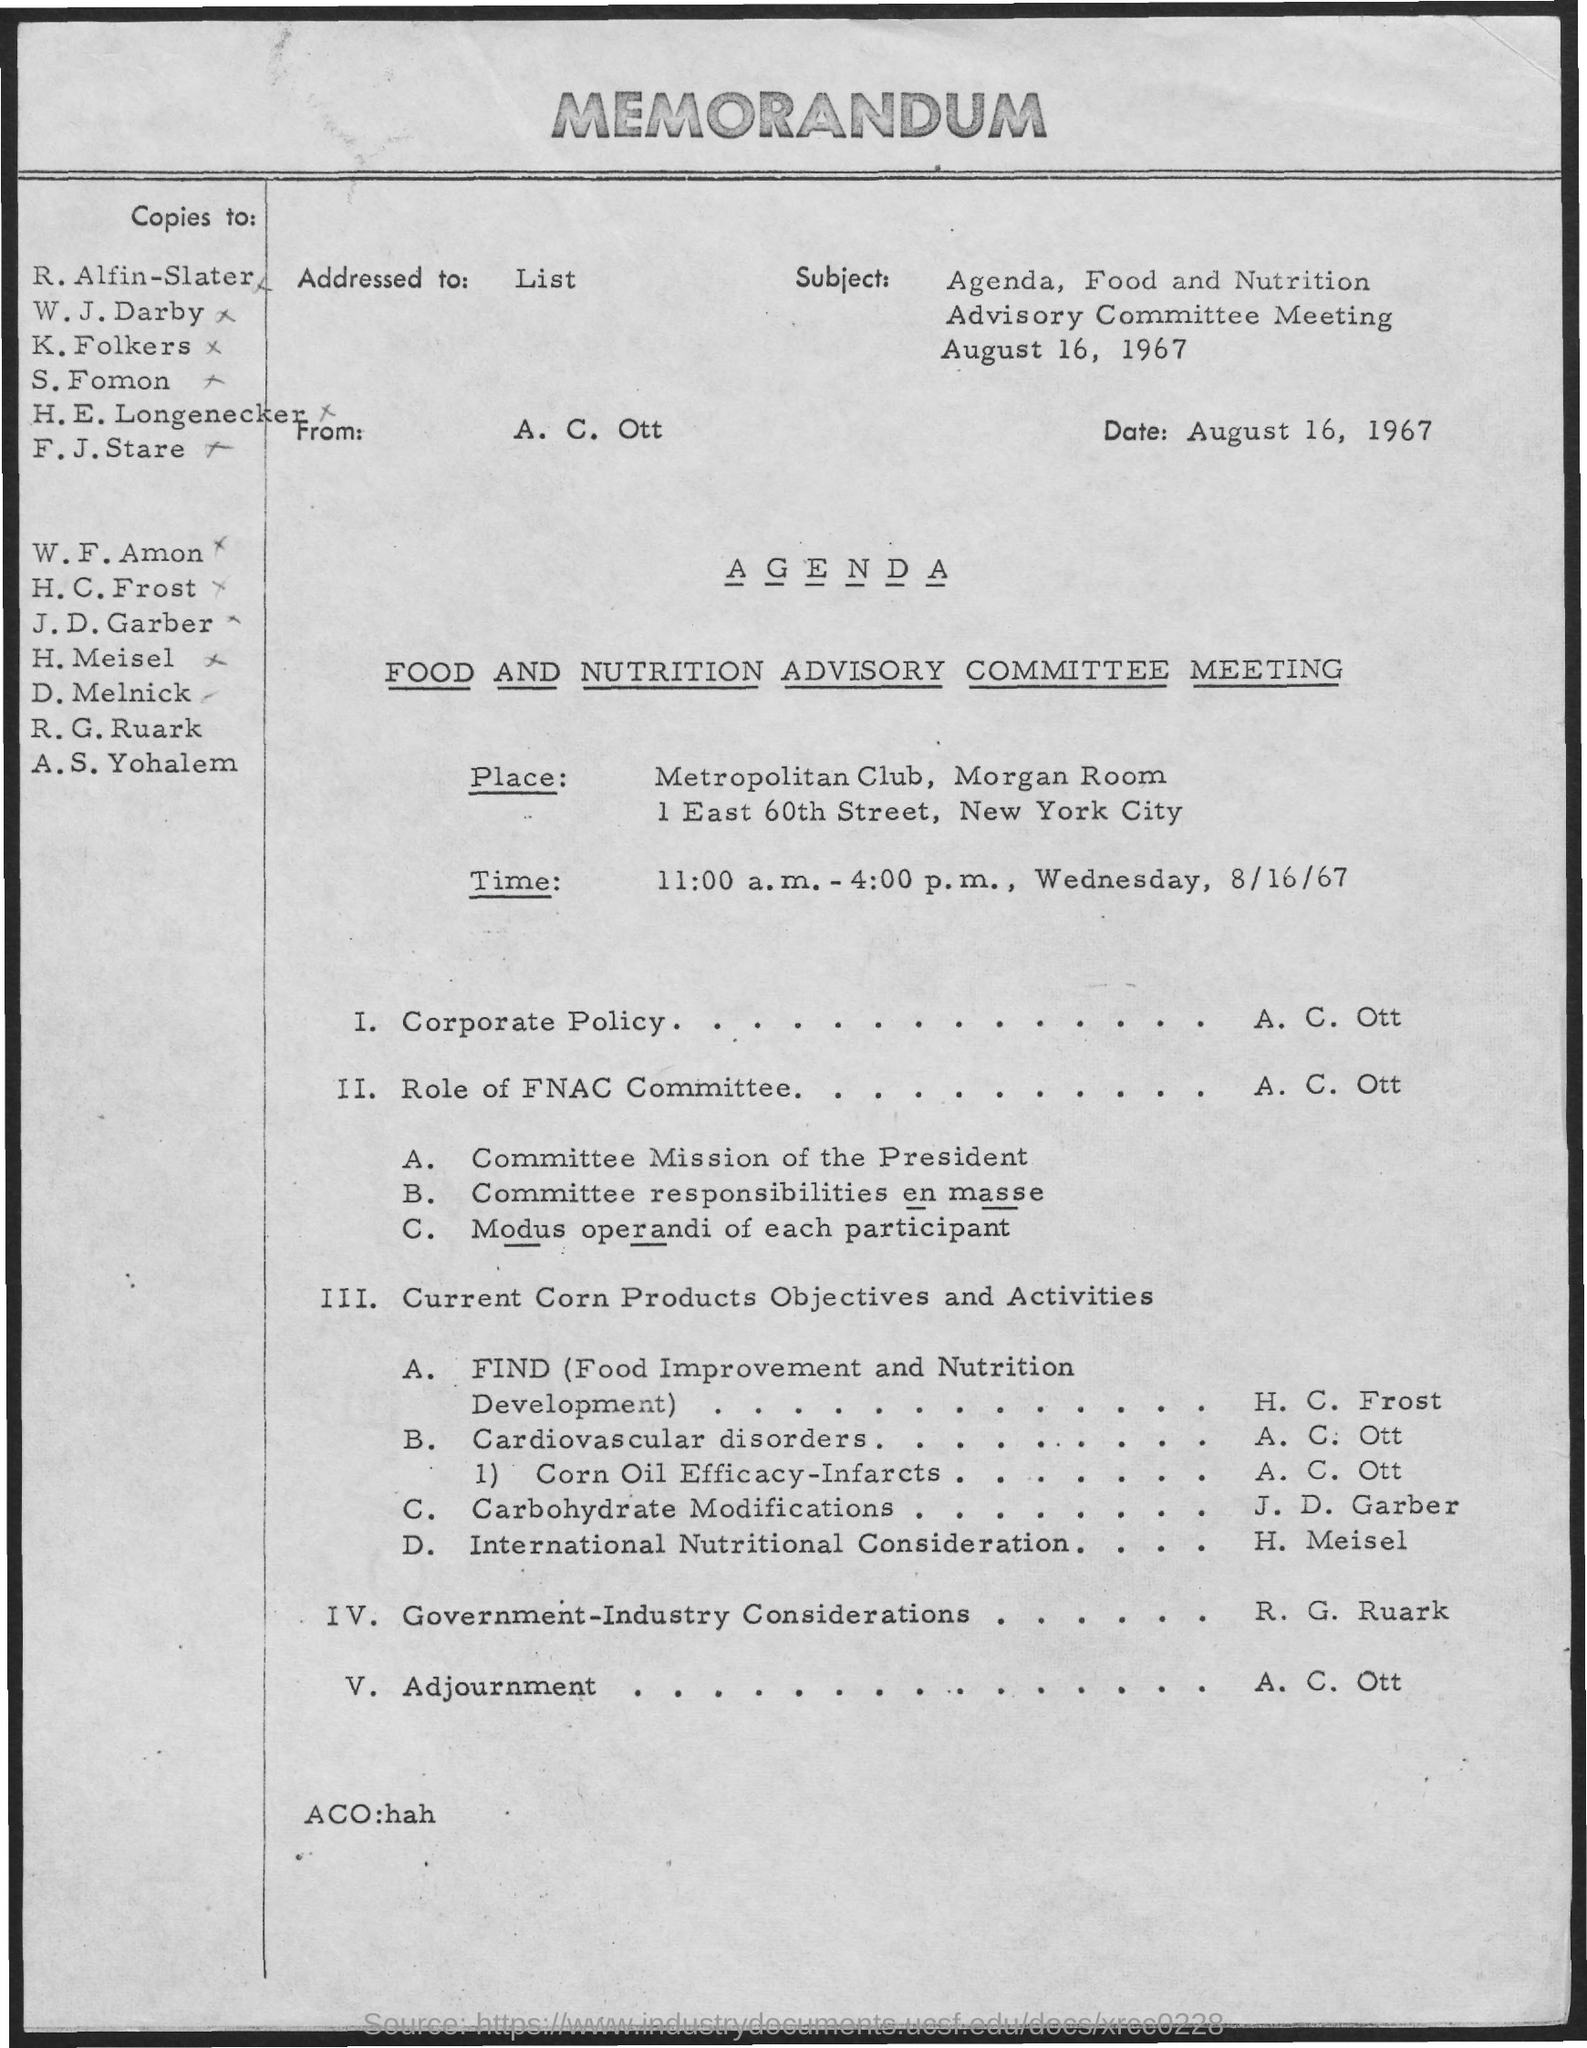Give some essential details in this illustration. The question, "Who is presenting Corporate Policy?" asks for the name of the person or entity responsible for presenting the Corporate Policy. The answer provided, "A. C. Ott..", is not sufficient information to determine the identity of the presenter. The meeting will take place on Wednesday, August 16th, 1967 from 11:00 A.M. to 4:00 P.M. The meeting is held at the Metropolitan Club in the Morgan Room. The memo was written on August 16, 1967. 